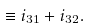Convert formula to latex. <formula><loc_0><loc_0><loc_500><loc_500>\equiv i _ { 3 1 } + i _ { 3 2 } .</formula> 